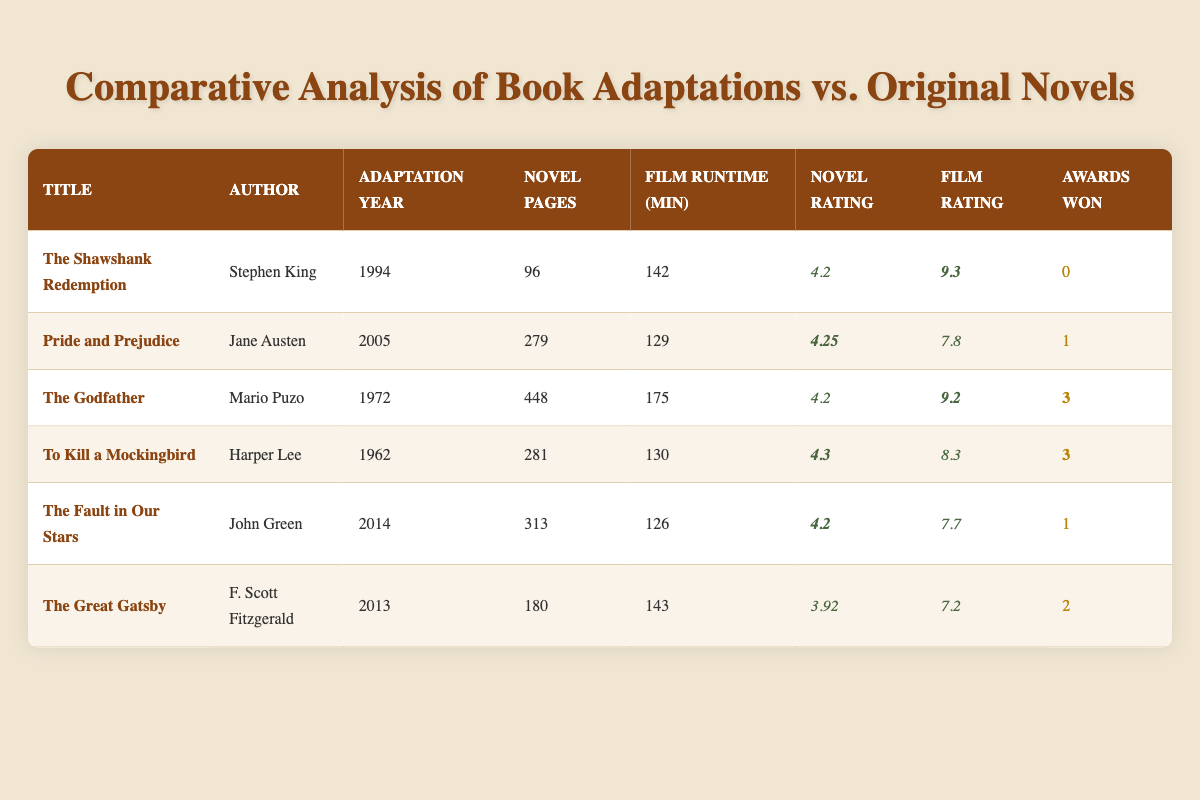What is the film runtime of "The Godfather"? The film runtime for "The Godfather" is stated directly in the table under the Film Runtime (min) column, which shows 175 minutes.
Answer: 175 minutes Who is the author of "Pride and Prejudice"? The author listed for "Pride and Prejudice" can be found in the Author column of the table, which indicates Jane Austen as the author.
Answer: Jane Austen Which adaptation won the most awards? By reviewing the Awards Won column, "The Godfather" and "To Kill a Mockingbird" both won 3 awards, but they are the highest values in that column compared to others.
Answer: The Godfather and To Kill a Mockingbird What is the average novel rating of all adaptations? To find the average, sum all the novel ratings (4.2 + 4.25 + 4.2 + 4.3 + 4.2 + 3.92 = 25.47) and divide by the number of adaptations (6). Therefore, the average novel rating is 25.47 / 6 = 4.245.
Answer: 4.245 Did "The Fault in Our Stars" receive any awards? The Awards Won column indicates that "The Fault in Our Stars" received 1 award, which confirms it did receive recognition.
Answer: Yes Which film has the longest runtime? By examining the Film Runtime column, "The Godfather" has the longest runtime at 175 minutes compared to the others listed.
Answer: The Godfather Is the film rating for "The Great Gatsby" higher than the novel rating? The film rating for "The Great Gatsby" is 7.2 and the novel rating is 3.92. Since 7.2 is greater than 3.92, this statement is true.
Answer: Yes What is the difference between the novel page count of "The Shawshank Redemption" and "The Great Gatsby"? The novel page count for "The Shawshank Redemption" is 96 and for "The Great Gatsby" is 180. The difference is calculated by subtracting: 180 - 96 = 84 pages.
Answer: 84 pages How many adaptations have a novel rating of 4.2 or higher? Looking at the Novel Rating column, the adaptations with ratings of 4.2 or higher are "The Shawshank Redemption", "Pride and Prejudice", "The Godfather", "To Kill a Mockingbird", and "The Fault in Our Stars". This totals to 5 adaptations.
Answer: 5 adaptations What is the highest film rating among the adaptations? In the Film Rating column, the highest rating is found under "The Shawshank Redemption", which is rated 9.3. No other adaptation exceeds this.
Answer: 9.3 